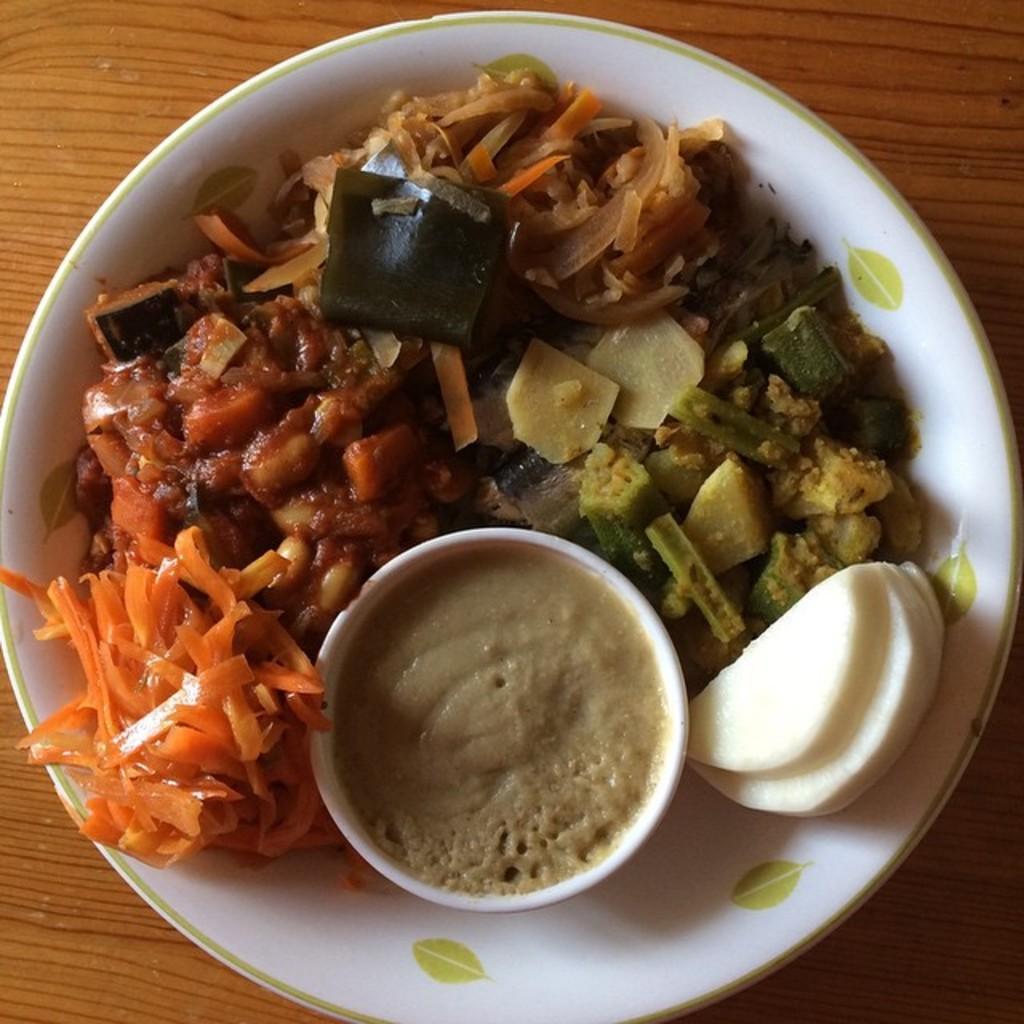How would you summarize this image in a sentence or two? This is a zoomed in picture. In the center there is a white color bowl containing some food items. In the background there is a wooden object seems to be a table. 